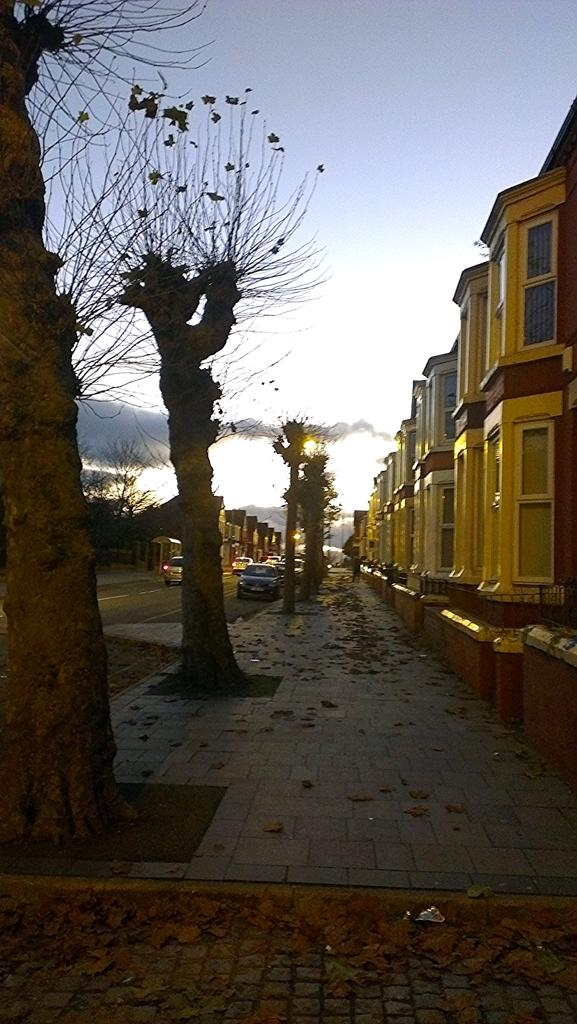What type of vegetation is present on the pavement in the image? There are trees on the pavement in the image. What can be seen on the road in the image? There are vehicles on the road in the image. What is visible in the background of the image? There are buildings in the background of the image. What is visible at the top of the image? The sky is visible at the top of the image. What type of bells can be heard ringing in the image? There are no bells present in the image, and therefore no sound can be heard. Can you see any fangs on the trees in the image? Trees do not have fangs, so this question is not applicable to the image. 